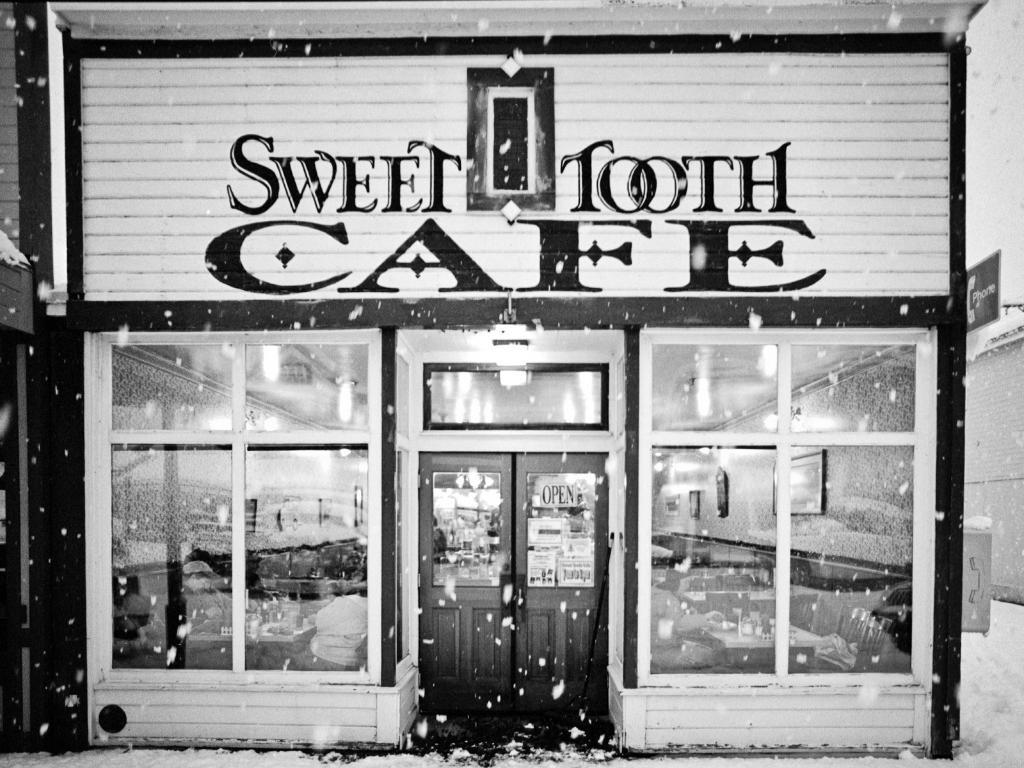What type of establishment is depicted in the image? There is a store in the image. Can you describe the entrance to the store? There is a door in the center of the store. Are there any other features that allow natural light to enter the store? Yes, there are windows in the store. What weather condition can be observed in the image? There is snow visible in the image. How many cats are in the jail cell in the image? There are no cats or jail cells present in the image; it features a store with a door and windows. 